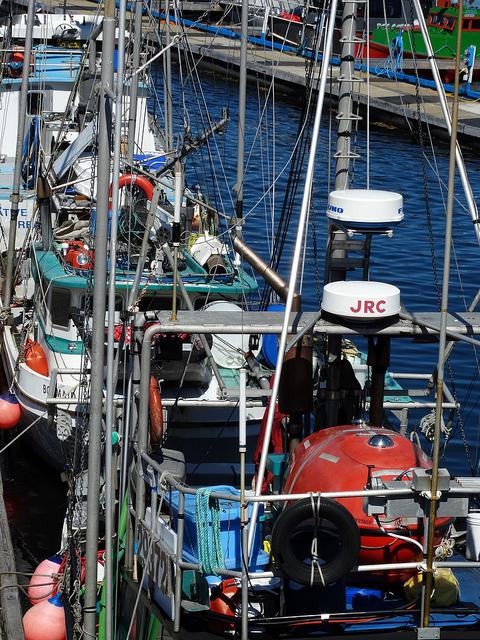What color are the round buoys on the left sides of these boats parked at the marina? Please explain your reasoning. red. They are a little faded but have the same coloring as an apple 